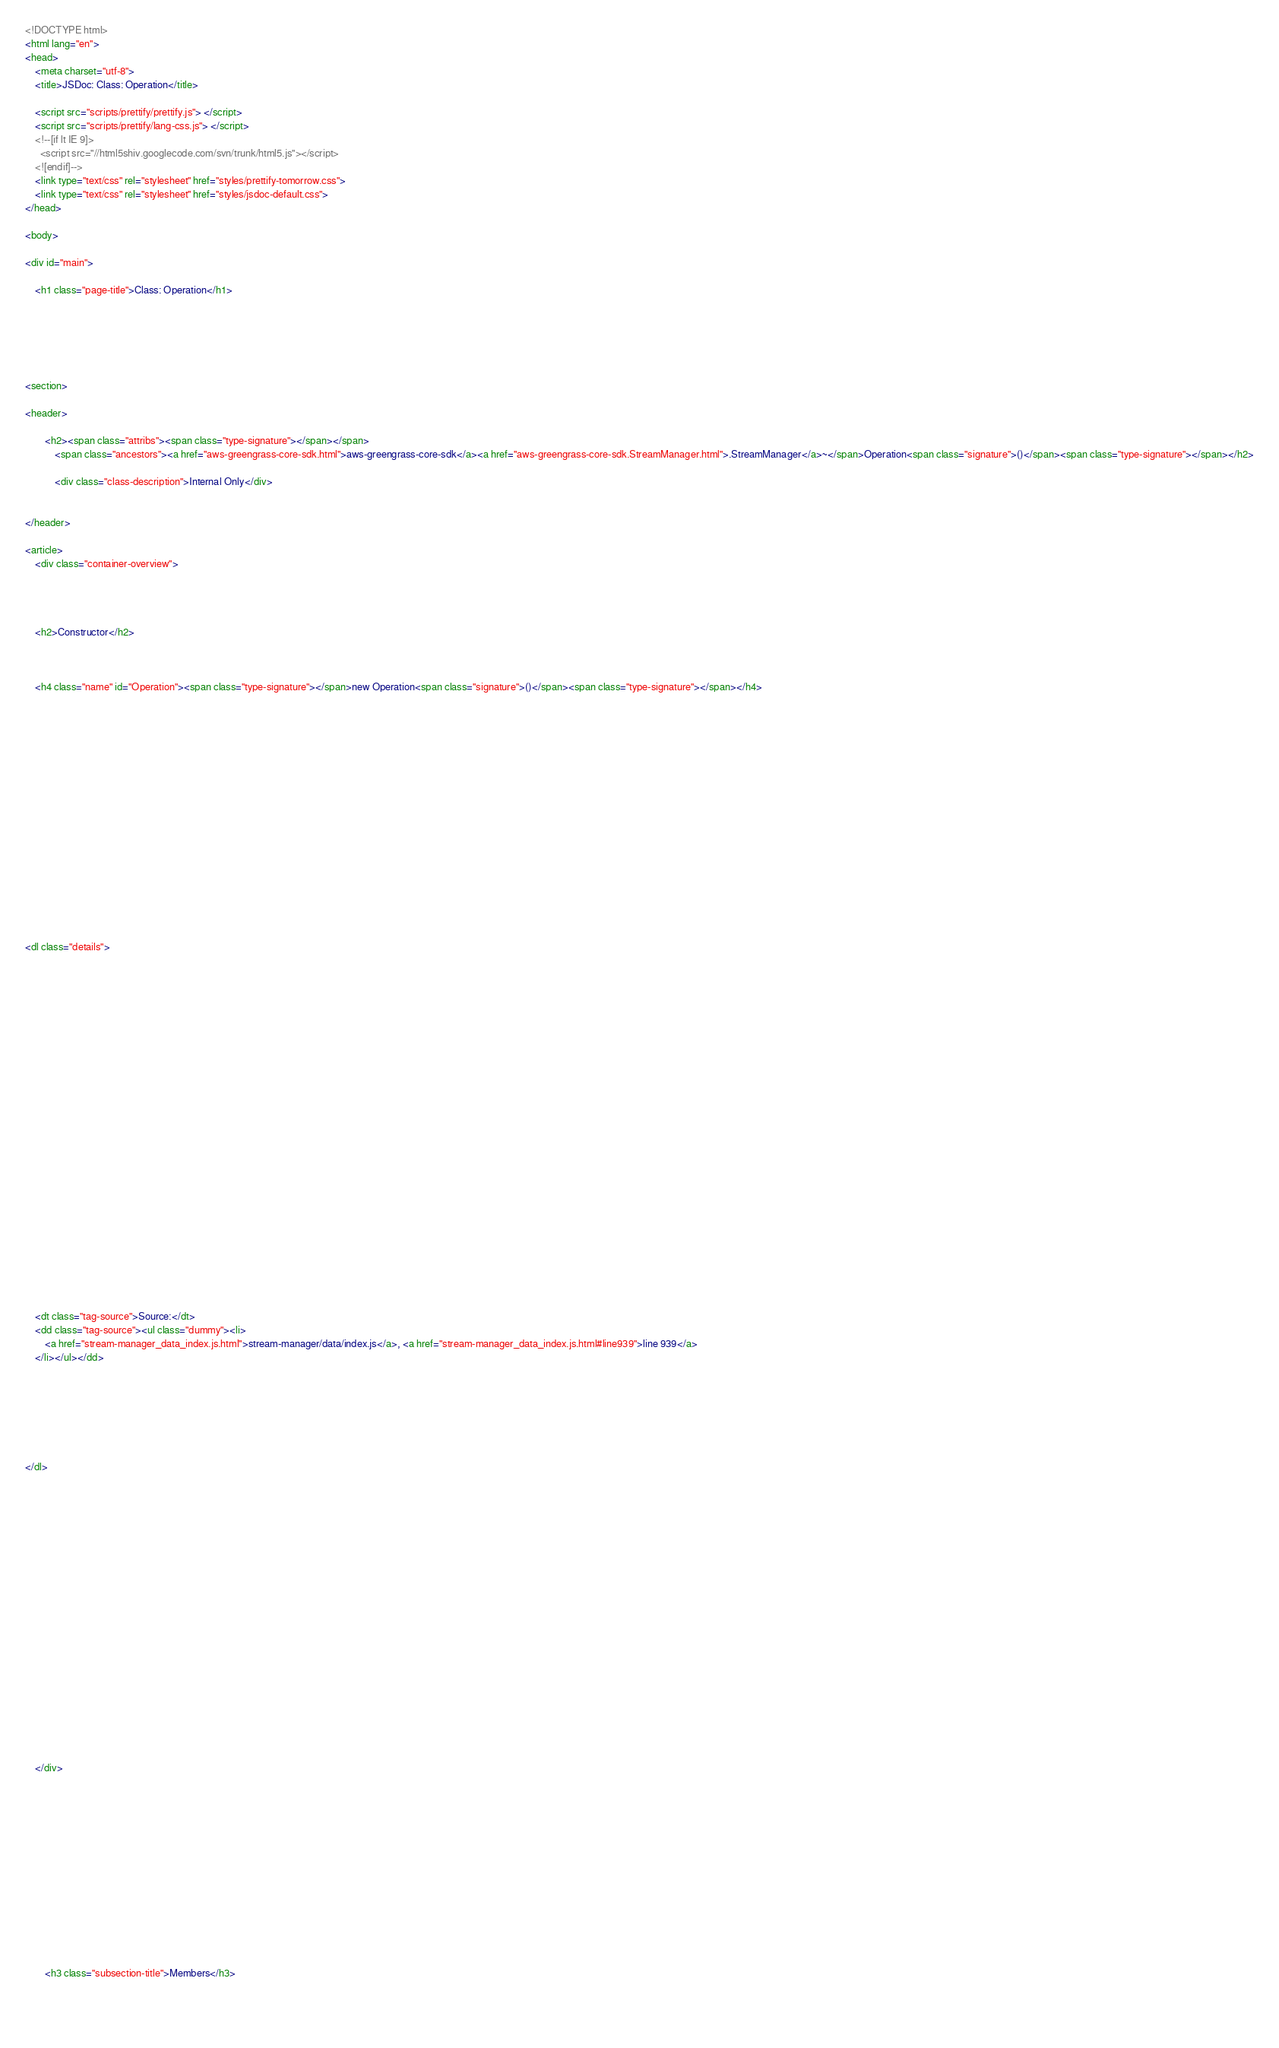Convert code to text. <code><loc_0><loc_0><loc_500><loc_500><_HTML_><!DOCTYPE html>
<html lang="en">
<head>
    <meta charset="utf-8">
    <title>JSDoc: Class: Operation</title>

    <script src="scripts/prettify/prettify.js"> </script>
    <script src="scripts/prettify/lang-css.js"> </script>
    <!--[if lt IE 9]>
      <script src="//html5shiv.googlecode.com/svn/trunk/html5.js"></script>
    <![endif]-->
    <link type="text/css" rel="stylesheet" href="styles/prettify-tomorrow.css">
    <link type="text/css" rel="stylesheet" href="styles/jsdoc-default.css">
</head>

<body>

<div id="main">

    <h1 class="page-title">Class: Operation</h1>

    




<section>

<header>
    
        <h2><span class="attribs"><span class="type-signature"></span></span>
            <span class="ancestors"><a href="aws-greengrass-core-sdk.html">aws-greengrass-core-sdk</a><a href="aws-greengrass-core-sdk.StreamManager.html">.StreamManager</a>~</span>Operation<span class="signature">()</span><span class="type-signature"></span></h2>
        
            <div class="class-description">Internal Only</div>
        
    
</header>

<article>
    <div class="container-overview">
    
        

    
    <h2>Constructor</h2>
    

    
    <h4 class="name" id="Operation"><span class="type-signature"></span>new Operation<span class="signature">()</span><span class="type-signature"></span></h4>
    

    















<dl class="details">

    

    

    

    

    

    

    

    

    

    

    

    

    
    <dt class="tag-source">Source:</dt>
    <dd class="tag-source"><ul class="dummy"><li>
        <a href="stream-manager_data_index.js.html">stream-manager/data/index.js</a>, <a href="stream-manager_data_index.js.html#line939">line 939</a>
    </li></ul></dd>
    

    

    

    
</dl>




















    
    </div>

    

    

    

    

    

    

    
        <h3 class="subsection-title">Members</h3>

        
            </code> 